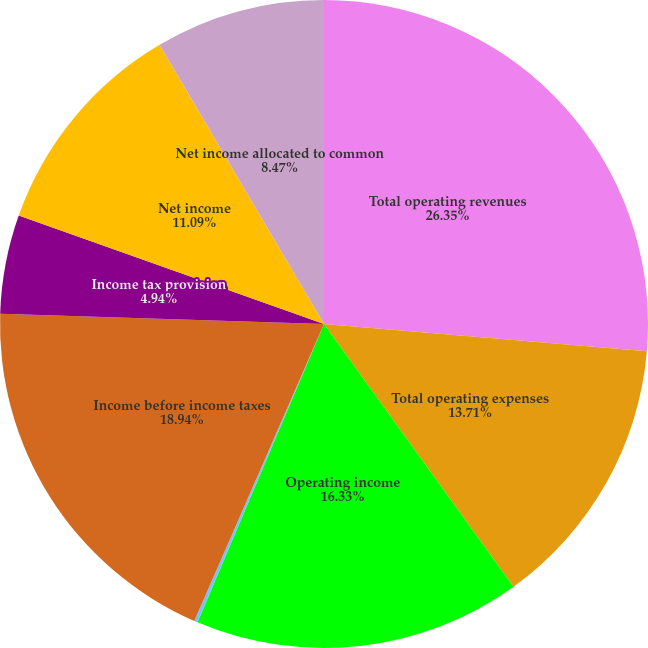Convert chart. <chart><loc_0><loc_0><loc_500><loc_500><pie_chart><fcel>Total operating revenues<fcel>Total operating expenses<fcel>Operating income<fcel>Total other income/(expense)<fcel>Income before income taxes<fcel>Income tax provision<fcel>Net income<fcel>Net income allocated to common<nl><fcel>26.34%<fcel>13.71%<fcel>16.33%<fcel>0.17%<fcel>18.94%<fcel>4.94%<fcel>11.09%<fcel>8.47%<nl></chart> 